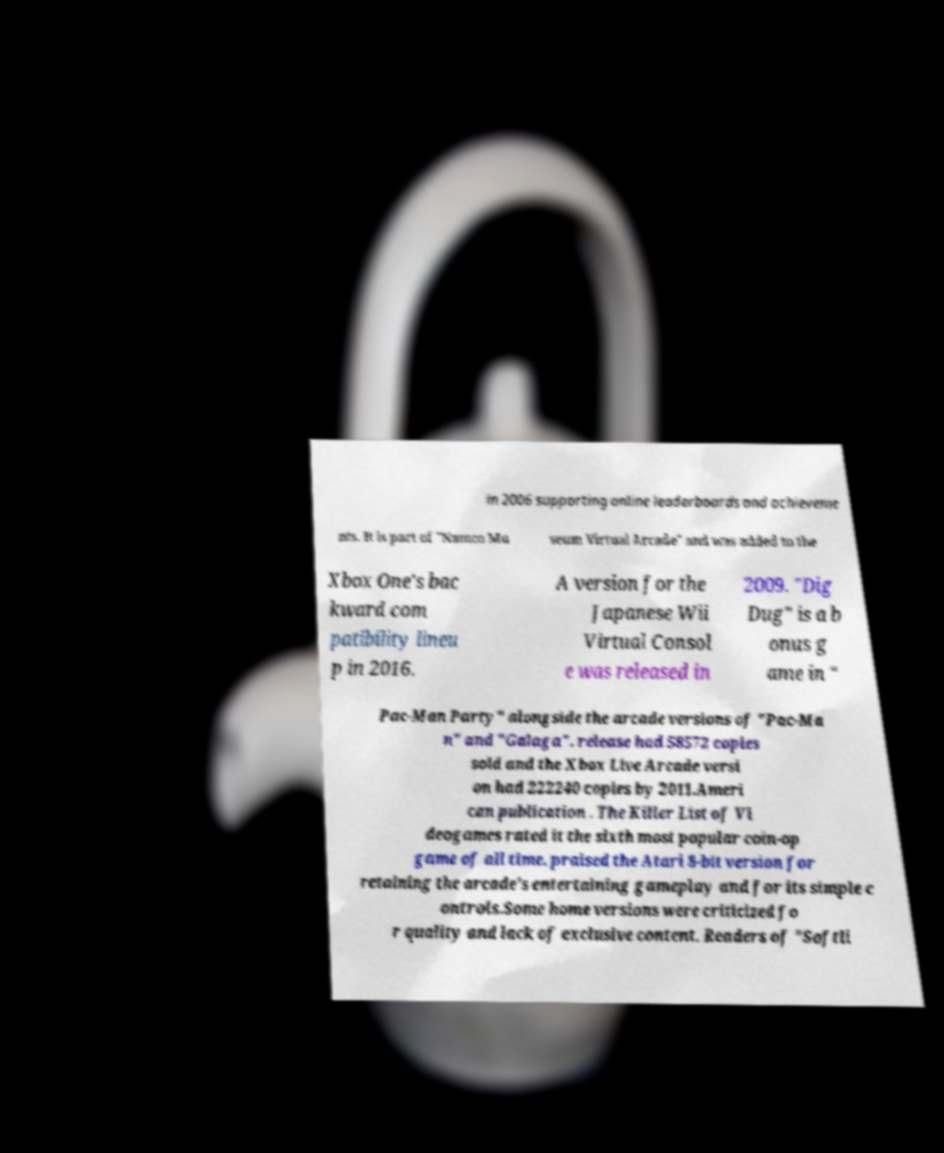Could you extract and type out the text from this image? in 2006 supporting online leaderboards and achieveme nts. It is part of "Namco Mu seum Virtual Arcade" and was added to the Xbox One's bac kward com patibility lineu p in 2016. A version for the Japanese Wii Virtual Consol e was released in 2009. "Dig Dug" is a b onus g ame in " Pac-Man Party" alongside the arcade versions of "Pac-Ma n" and "Galaga". release had 58572 copies sold and the Xbox Live Arcade versi on had 222240 copies by 2011.Ameri can publication . The Killer List of Vi deogames rated it the sixth most popular coin-op game of all time. praised the Atari 8-bit version for retaining the arcade's entertaining gameplay and for its simple c ontrols.Some home versions were criticized fo r quality and lack of exclusive content. Readers of "Softli 